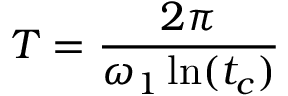<formula> <loc_0><loc_0><loc_500><loc_500>T = \frac { 2 \pi } { \omega _ { 1 } \ln ( t _ { c } ) }</formula> 